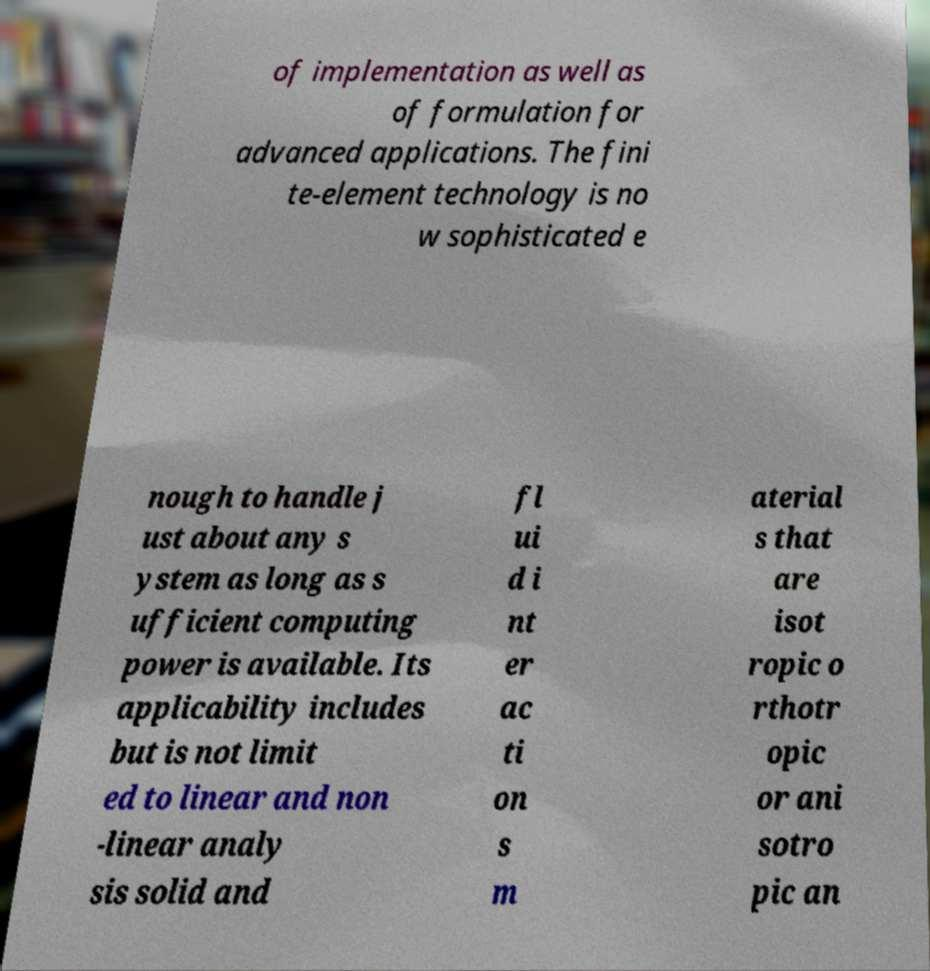Please read and relay the text visible in this image. What does it say? of implementation as well as of formulation for advanced applications. The fini te-element technology is no w sophisticated e nough to handle j ust about any s ystem as long as s ufficient computing power is available. Its applicability includes but is not limit ed to linear and non -linear analy sis solid and fl ui d i nt er ac ti on s m aterial s that are isot ropic o rthotr opic or ani sotro pic an 